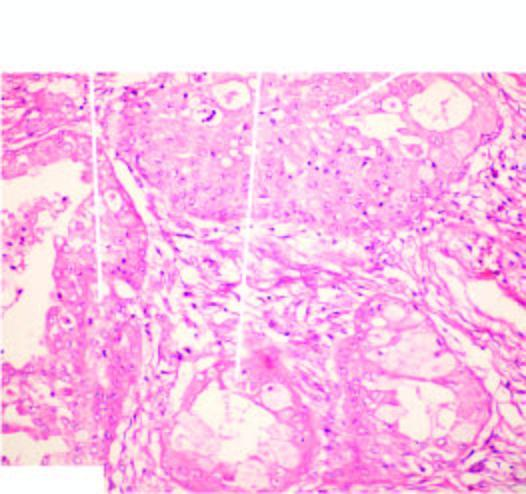what shows combination of mucinous, squamous and intermediate cells?
Answer the question using a single word or phrase. Tumour 